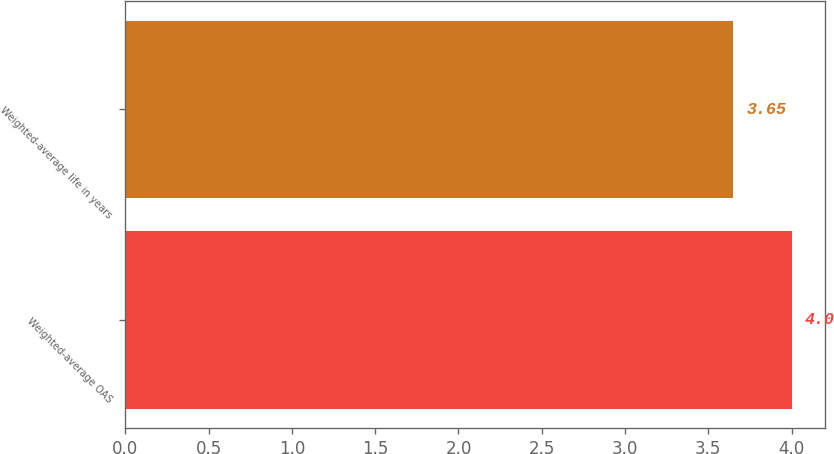Convert chart to OTSL. <chart><loc_0><loc_0><loc_500><loc_500><bar_chart><fcel>Weighted-average OAS<fcel>Weighted-average life in years<nl><fcel>4<fcel>3.65<nl></chart> 